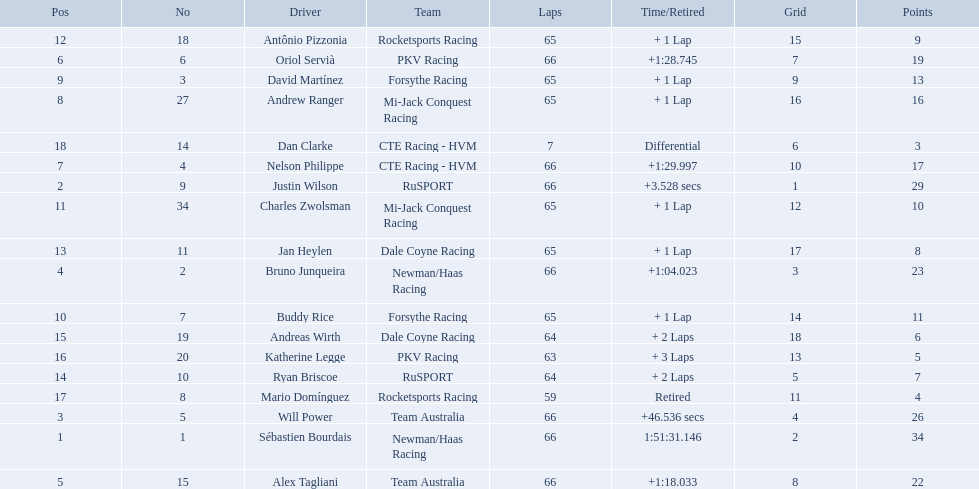Who are all the drivers? Sébastien Bourdais, Justin Wilson, Will Power, Bruno Junqueira, Alex Tagliani, Oriol Servià, Nelson Philippe, Andrew Ranger, David Martínez, Buddy Rice, Charles Zwolsman, Antônio Pizzonia, Jan Heylen, Ryan Briscoe, Andreas Wirth, Katherine Legge, Mario Domínguez, Dan Clarke. What position did they reach? 1, 2, 3, 4, 5, 6, 7, 8, 9, 10, 11, 12, 13, 14, 15, 16, 17, 18. What is the number for each driver? 1, 9, 5, 2, 15, 6, 4, 27, 3, 7, 34, 18, 11, 10, 19, 20, 8, 14. And which player's number and position match? Sébastien Bourdais. 